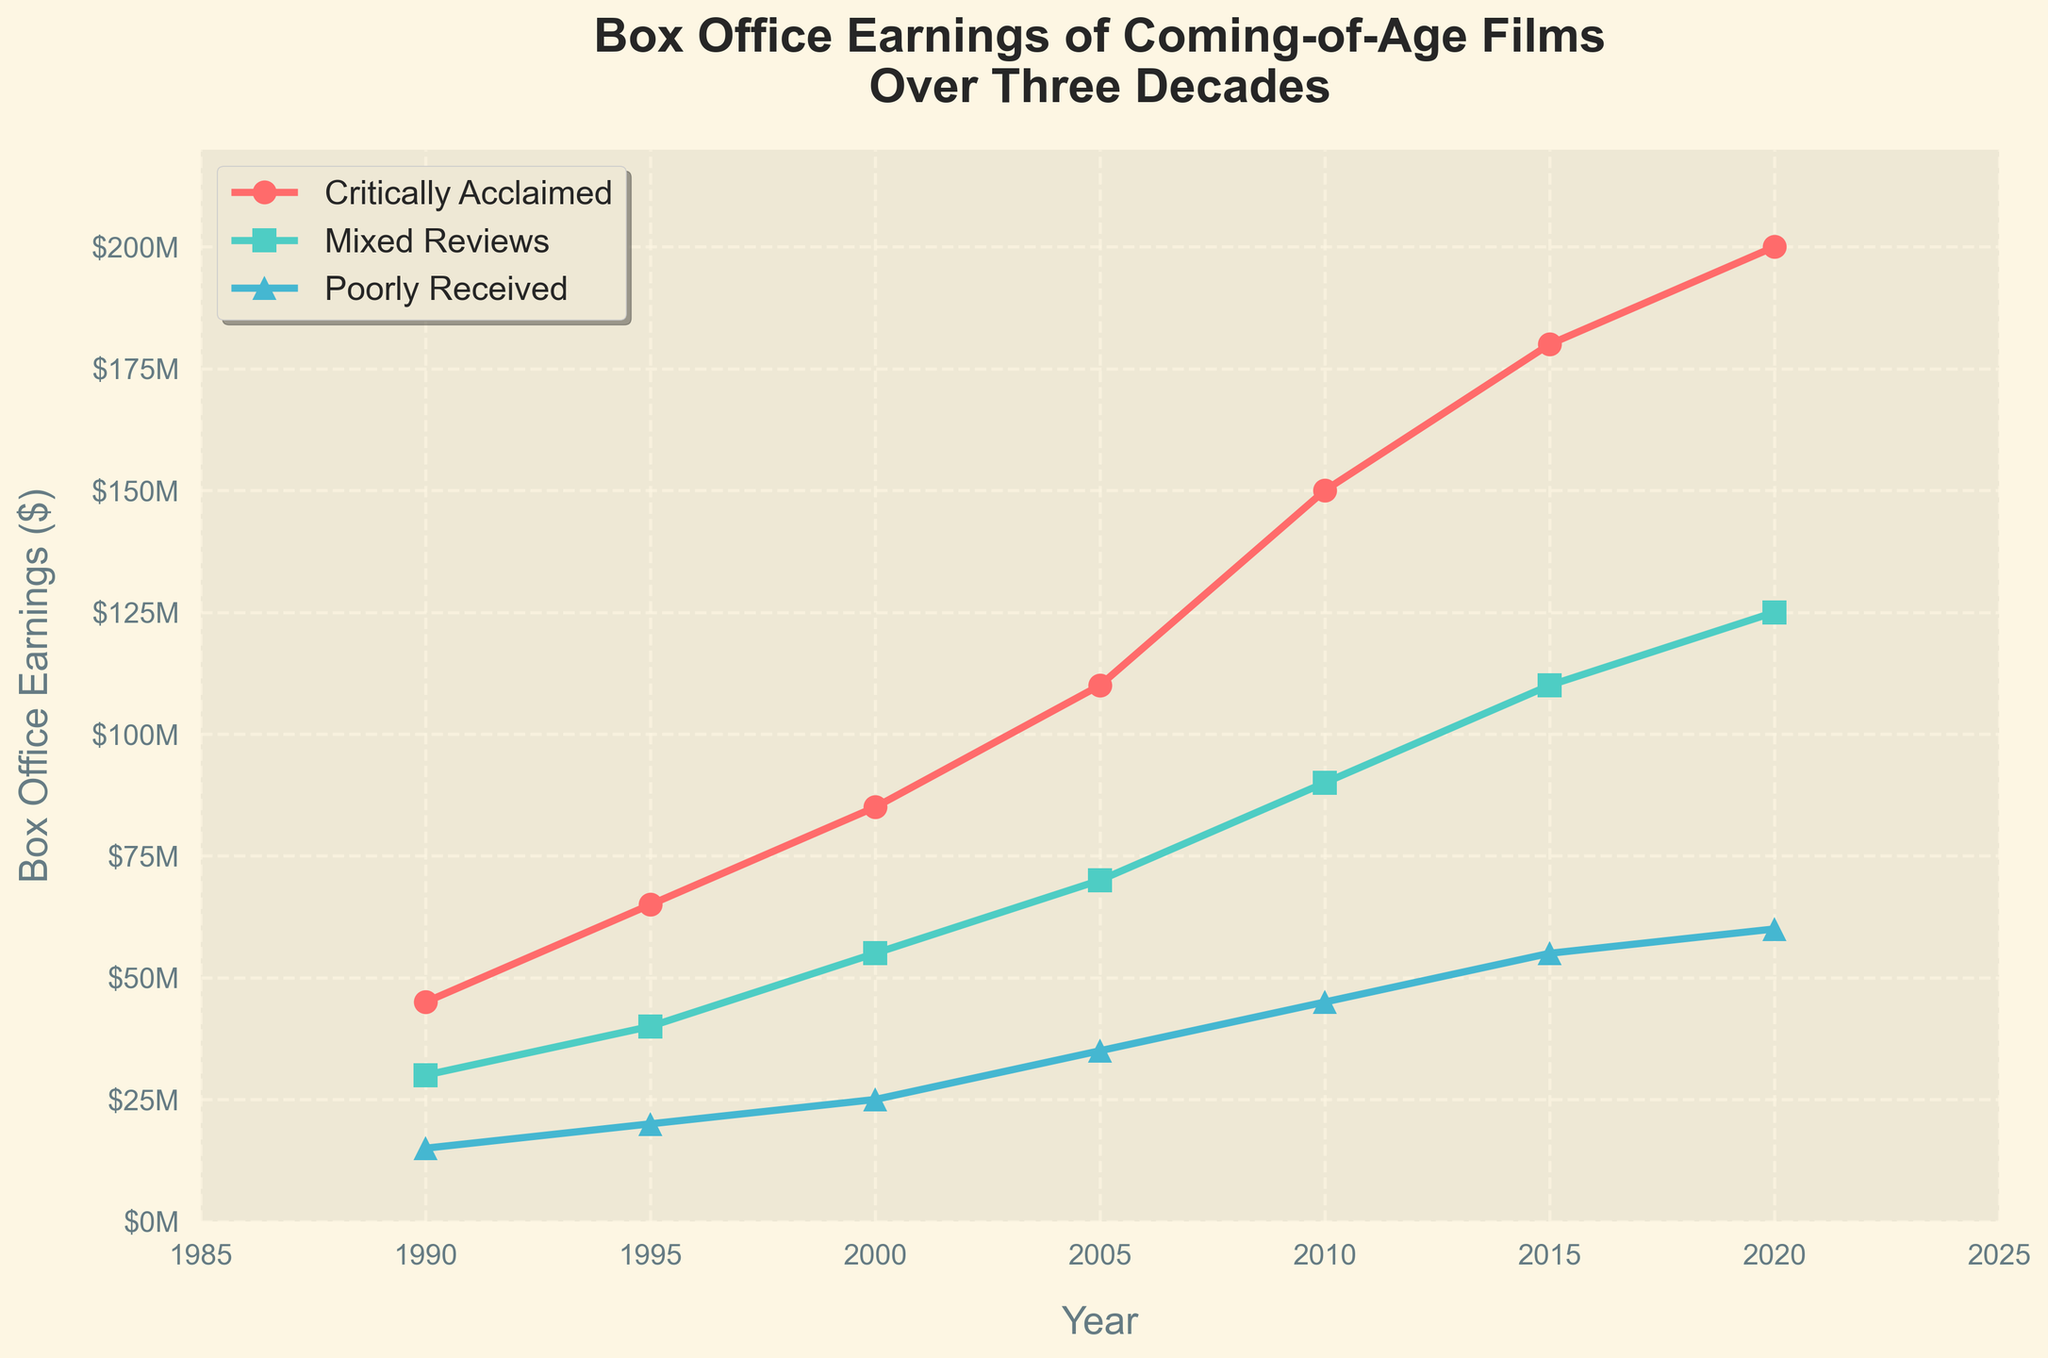What's the trend in box office earnings for critically acclaimed coming-of-age films over the three decades? Look at the red line representing critically acclaimed films from 1990 to 2020. Notice the steady increase in earnings over the years. From $45 million in 1990 to $200 million in 2020, there's a clear upward trend.
Answer: Steady increase What is the difference in box office earnings between critically acclaimed and poorly received films in 2020? Compare the endpoints of the red line (critically acclaimed) and blue line (poorly received) in 2020. The red line is at $200 million and the blue line is at $60 million. Subtract the earnings of poorly received films from that of critically acclaimed films: $200 million - $60 million.
Answer: $140 million Between which years did films with mixed reviews see the highest increase in box office earnings? Look at the turquoise line for mixed reviews and find the segment with the steepest incline. The earnings jump from $55 million in 2000 to $70 million in 2005 represents an increase of $15 million, whereas the increase from 2005 to 2010 is $20 million. However, the highest increase is from 2010 to 2015, where it goes from $90 million to $110 million, an increase of $20 million.
Answer: 2000-2005 Are there any decades where poorly received movies saw a significant increase in box office earnings? Look at the blue line representing poorly received films. The most noticeable increase is between 1990 to 2000, where it grows from $15 million to $25 million. Another noticeable increase is from 2010 to 2020, from $45 million to $60 million, but it is less steep.
Answer: 1990-2000 Which category of films consistently earned the most at the box office throughout the three decades? Observe the three lines on the chart. The red line (critically acclaimed) is always above the other two categories across all years.
Answer: Critically acclaimed What was the total box office earnings for mixed review films in 2000 and 2010 combined? Look at the turquoise line to find the earnings for mixed review films in 2000 ($55 million) and 2010 ($90 million). Add these two numbers together: $55 million + $90 million.
Answer: $145 million How did the gap between critically acclaimed and mixed review films change from 2005 to 2020? Compare the differences between red and turquoise lines at 2005 and 2020. In 2005, the gap is $110 million - $70 million = $40 million. In 2020, it is $200 million - $125 million = $75 million. The gap increased from $40 million to $75 million.
Answer: Increased by $35 million Which category saw the least growth in box office earnings from 1990 to 2020? Compare the start and end points for all three categories. The blue line (poorly received) grows from $15 million in 1990 to $60 million in 2020, an increase of $45 million. Both other categories have larger increases.
Answer: Poorly received What visual feature helps to easily distinguish the category of 'Mixed Reviews' films? Observe the chart's visual attributes: the turquoise line, which represents 'Mixed Reviews' films, is marked with square markers.
Answer: Turquoise line with square markers Which year shows the highest box office earnings for films with mixed reviews, and what is the earnings amount? Look at the peak of the turquoise line. The highest point is in 2020, where the earnings are $125 million.
Answer: 2020, $125 million 